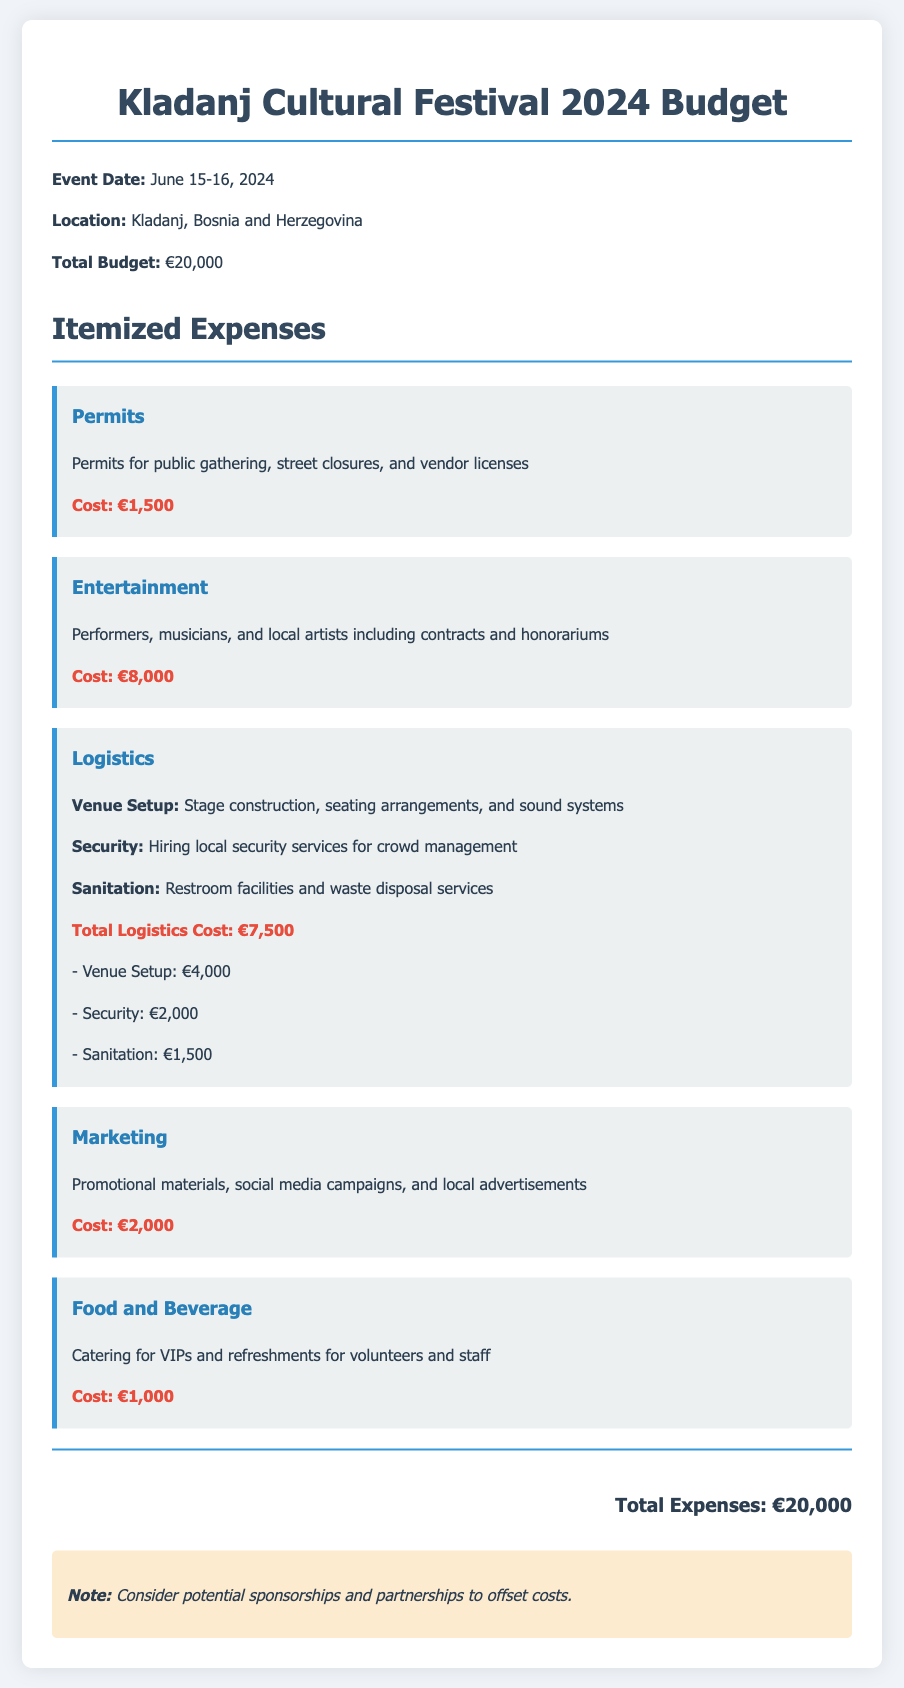What is the total budget for the Kladanj Cultural Festival? The total budget is clearly stated at the beginning of the document.
Answer: €20,000 When is the Kladanj Cultural Festival scheduled to take place? The event date is mentioned in the document.
Answer: June 15-16, 2024 How much is allocated for permits? The permits section specifies the exact cost.
Answer: €1,500 What is the cost for entertainment? The entertainment section details the budget allocation for performers and musicians.
Answer: €8,000 What are the total logistics expenses? The logistics section provides the sum of venue setup, security, and sanitation costs.
Answer: €7,500 How much is budgeted for marketing? The marketing expenses section outlines the specified amount for promotional activities.
Answer: €2,000 What is included in the logistics expenses? The logistics section lists different components included in the total logistics cost.
Answer: Venue Setup, Security, Sanitation What is the amount set aside for food and beverage? The food and beverage section indicates the amount allocated for catering and refreshments.
Answer: €1,000 What key note is mentioned in the document? The notes section provides an important consideration regarding sponsorships and partnerships.
Answer: Consider potential sponsorships and partnerships to offset costs 